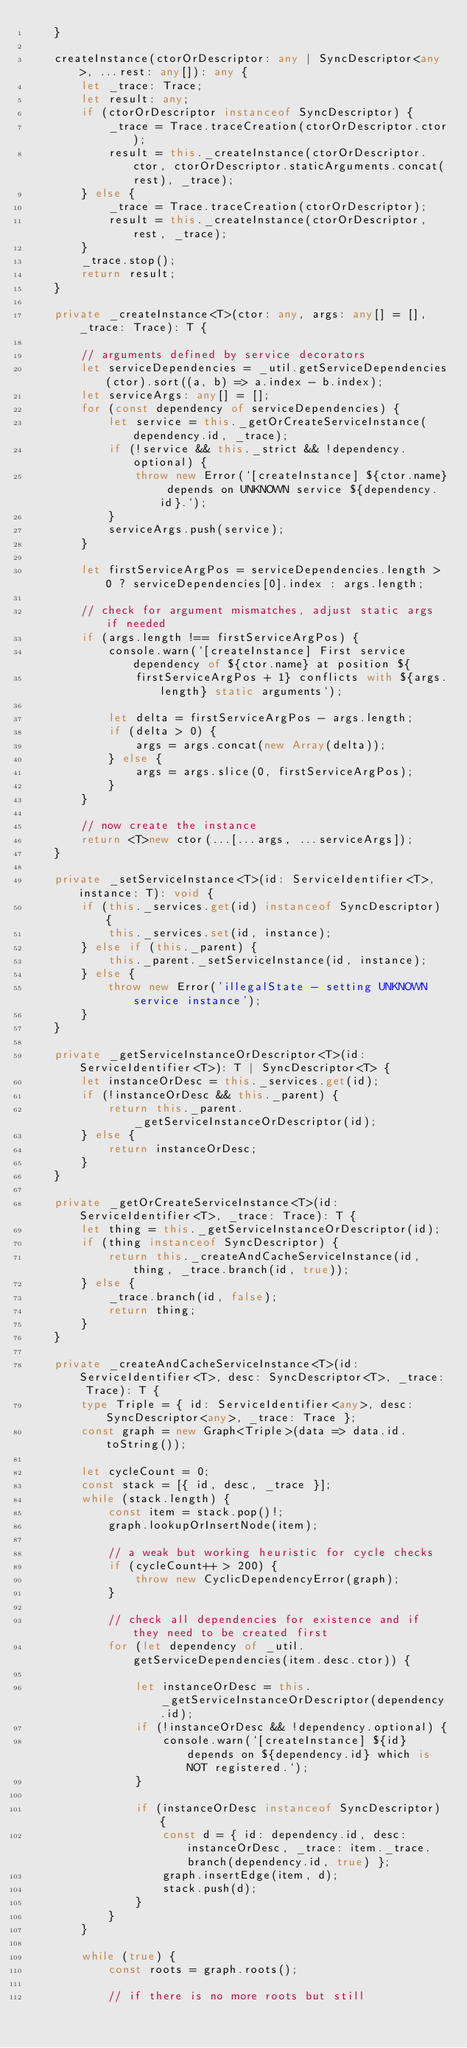<code> <loc_0><loc_0><loc_500><loc_500><_TypeScript_>	}

	createInstance(ctorOrDescriptor: any | SyncDescriptor<any>, ...rest: any[]): any {
		let _trace: Trace;
		let result: any;
		if (ctorOrDescriptor instanceof SyncDescriptor) {
			_trace = Trace.traceCreation(ctorOrDescriptor.ctor);
			result = this._createInstance(ctorOrDescriptor.ctor, ctorOrDescriptor.staticArguments.concat(rest), _trace);
		} else {
			_trace = Trace.traceCreation(ctorOrDescriptor);
			result = this._createInstance(ctorOrDescriptor, rest, _trace);
		}
		_trace.stop();
		return result;
	}

	private _createInstance<T>(ctor: any, args: any[] = [], _trace: Trace): T {

		// arguments defined by service decorators
		let serviceDependencies = _util.getServiceDependencies(ctor).sort((a, b) => a.index - b.index);
		let serviceArgs: any[] = [];
		for (const dependency of serviceDependencies) {
			let service = this._getOrCreateServiceInstance(dependency.id, _trace);
			if (!service && this._strict && !dependency.optional) {
				throw new Error(`[createInstance] ${ctor.name} depends on UNKNOWN service ${dependency.id}.`);
			}
			serviceArgs.push(service);
		}

		let firstServiceArgPos = serviceDependencies.length > 0 ? serviceDependencies[0].index : args.length;

		// check for argument mismatches, adjust static args if needed
		if (args.length !== firstServiceArgPos) {
			console.warn(`[createInstance] First service dependency of ${ctor.name} at position ${
				firstServiceArgPos + 1} conflicts with ${args.length} static arguments`);

			let delta = firstServiceArgPos - args.length;
			if (delta > 0) {
				args = args.concat(new Array(delta));
			} else {
				args = args.slice(0, firstServiceArgPos);
			}
		}

		// now create the instance
		return <T>new ctor(...[...args, ...serviceArgs]);
	}

	private _setServiceInstance<T>(id: ServiceIdentifier<T>, instance: T): void {
		if (this._services.get(id) instanceof SyncDescriptor) {
			this._services.set(id, instance);
		} else if (this._parent) {
			this._parent._setServiceInstance(id, instance);
		} else {
			throw new Error('illegalState - setting UNKNOWN service instance');
		}
	}

	private _getServiceInstanceOrDescriptor<T>(id: ServiceIdentifier<T>): T | SyncDescriptor<T> {
		let instanceOrDesc = this._services.get(id);
		if (!instanceOrDesc && this._parent) {
			return this._parent._getServiceInstanceOrDescriptor(id);
		} else {
			return instanceOrDesc;
		}
	}

	private _getOrCreateServiceInstance<T>(id: ServiceIdentifier<T>, _trace: Trace): T {
		let thing = this._getServiceInstanceOrDescriptor(id);
		if (thing instanceof SyncDescriptor) {
			return this._createAndCacheServiceInstance(id, thing, _trace.branch(id, true));
		} else {
			_trace.branch(id, false);
			return thing;
		}
	}

	private _createAndCacheServiceInstance<T>(id: ServiceIdentifier<T>, desc: SyncDescriptor<T>, _trace: Trace): T {
		type Triple = { id: ServiceIdentifier<any>, desc: SyncDescriptor<any>, _trace: Trace };
		const graph = new Graph<Triple>(data => data.id.toString());

		let cycleCount = 0;
		const stack = [{ id, desc, _trace }];
		while (stack.length) {
			const item = stack.pop()!;
			graph.lookupOrInsertNode(item);

			// a weak but working heuristic for cycle checks
			if (cycleCount++ > 200) {
				throw new CyclicDependencyError(graph);
			}

			// check all dependencies for existence and if they need to be created first
			for (let dependency of _util.getServiceDependencies(item.desc.ctor)) {

				let instanceOrDesc = this._getServiceInstanceOrDescriptor(dependency.id);
				if (!instanceOrDesc && !dependency.optional) {
					console.warn(`[createInstance] ${id} depends on ${dependency.id} which is NOT registered.`);
				}

				if (instanceOrDesc instanceof SyncDescriptor) {
					const d = { id: dependency.id, desc: instanceOrDesc, _trace: item._trace.branch(dependency.id, true) };
					graph.insertEdge(item, d);
					stack.push(d);
				}
			}
		}

		while (true) {
			const roots = graph.roots();

			// if there is no more roots but still</code> 